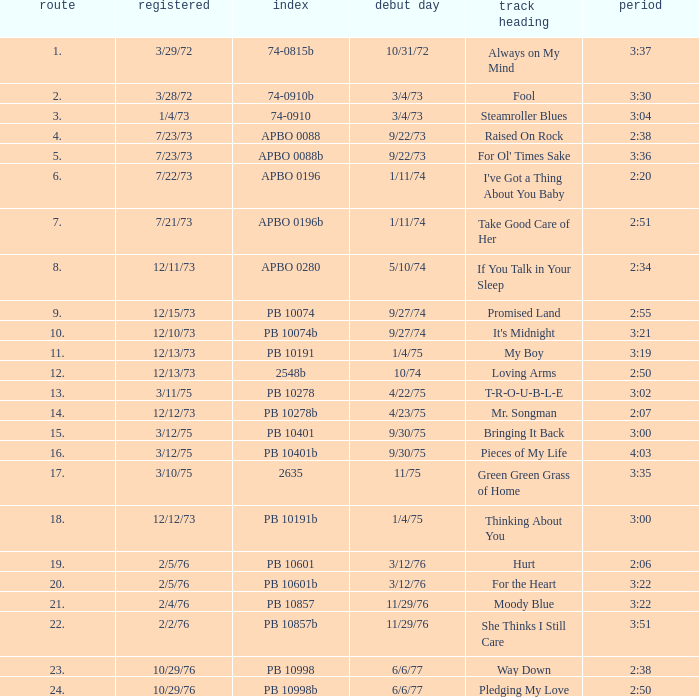I want the sum of tracks for raised on rock 4.0. 